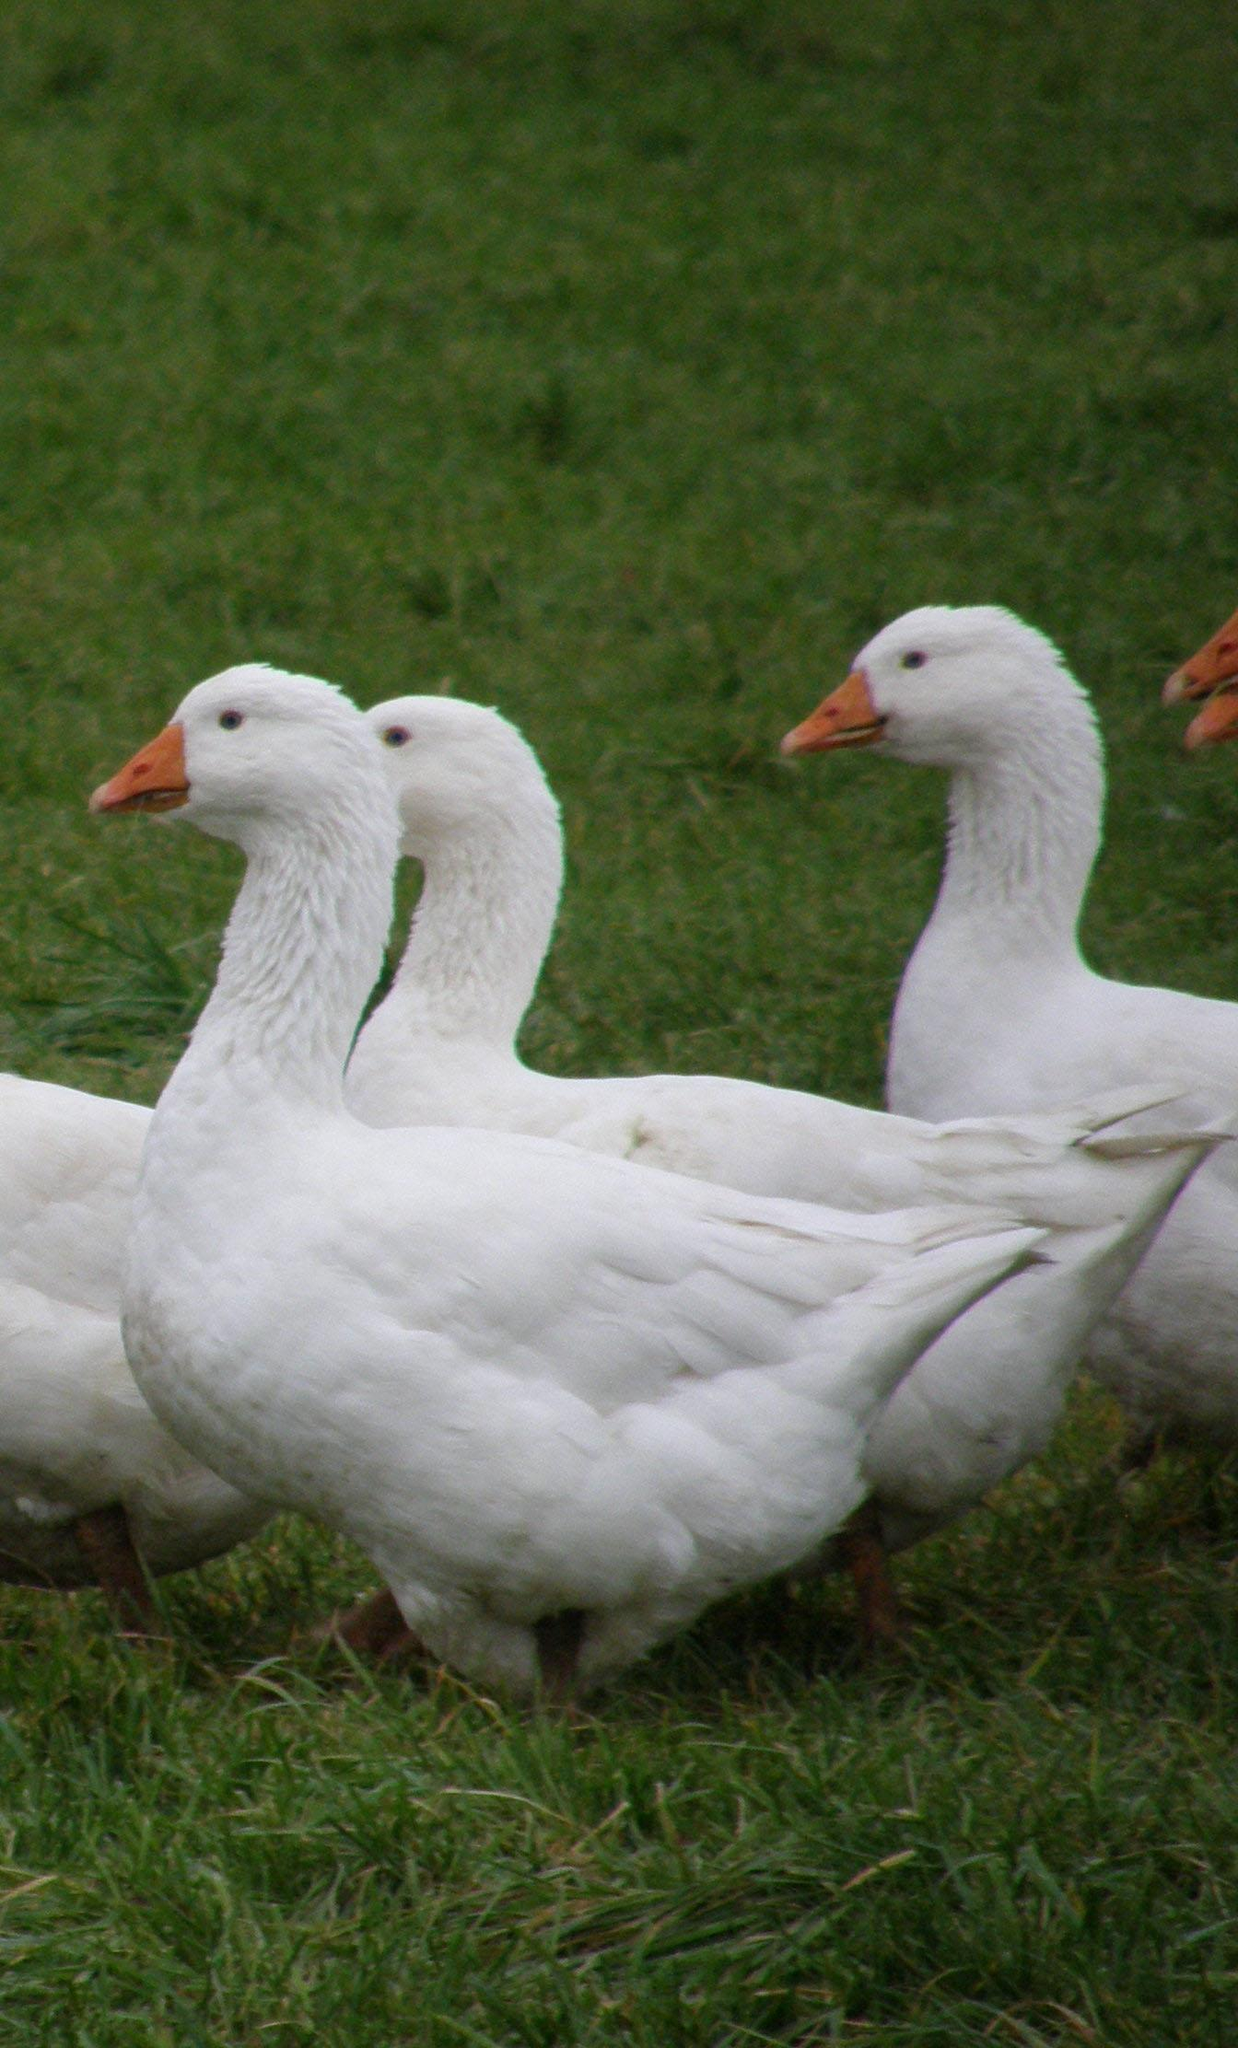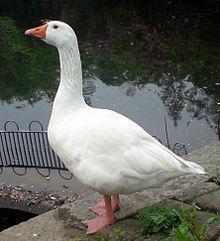The first image is the image on the left, the second image is the image on the right. Given the left and right images, does the statement "The right image does not depict more geese than the left image." hold true? Answer yes or no. Yes. 